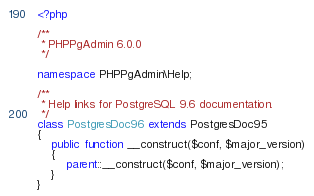<code> <loc_0><loc_0><loc_500><loc_500><_PHP_><?php

/**
 * PHPPgAdmin 6.0.0
 */

namespace PHPPgAdmin\Help;

/**
 * Help links for PostgreSQL 9.6 documentation.
 */
class PostgresDoc96 extends PostgresDoc95
{
    public function __construct($conf, $major_version)
    {
        parent::__construct($conf, $major_version);
    }
}
</code> 